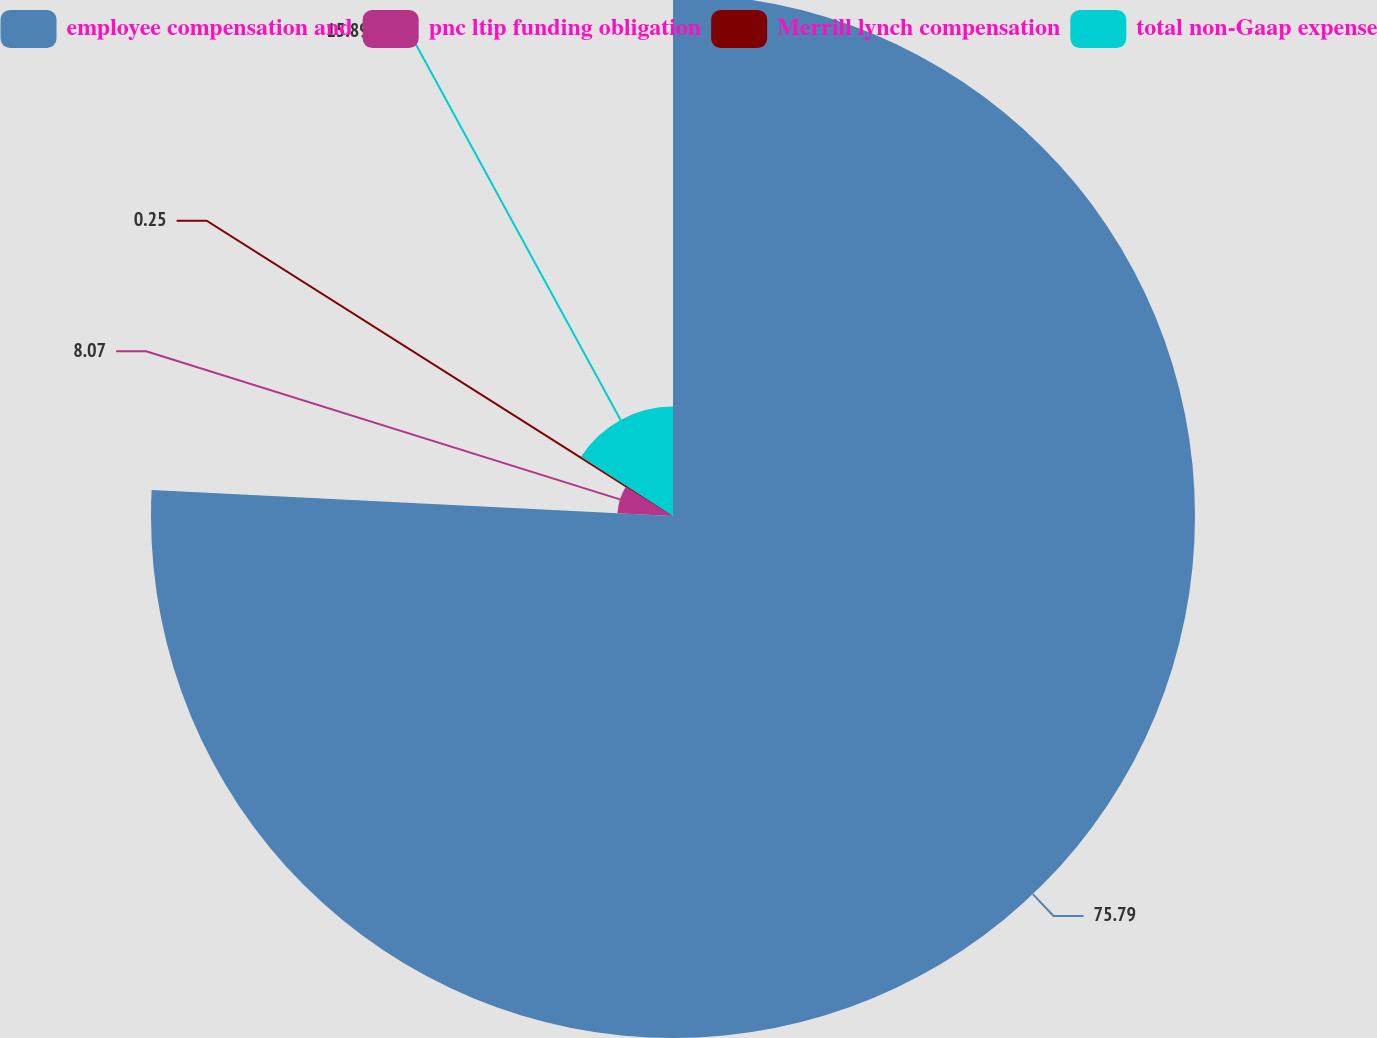<chart> <loc_0><loc_0><loc_500><loc_500><pie_chart><fcel>employee compensation and<fcel>pnc ltip funding obligation<fcel>Merrill lynch compensation<fcel>total non-Gaap expense<nl><fcel>75.79%<fcel>8.07%<fcel>0.25%<fcel>15.89%<nl></chart> 